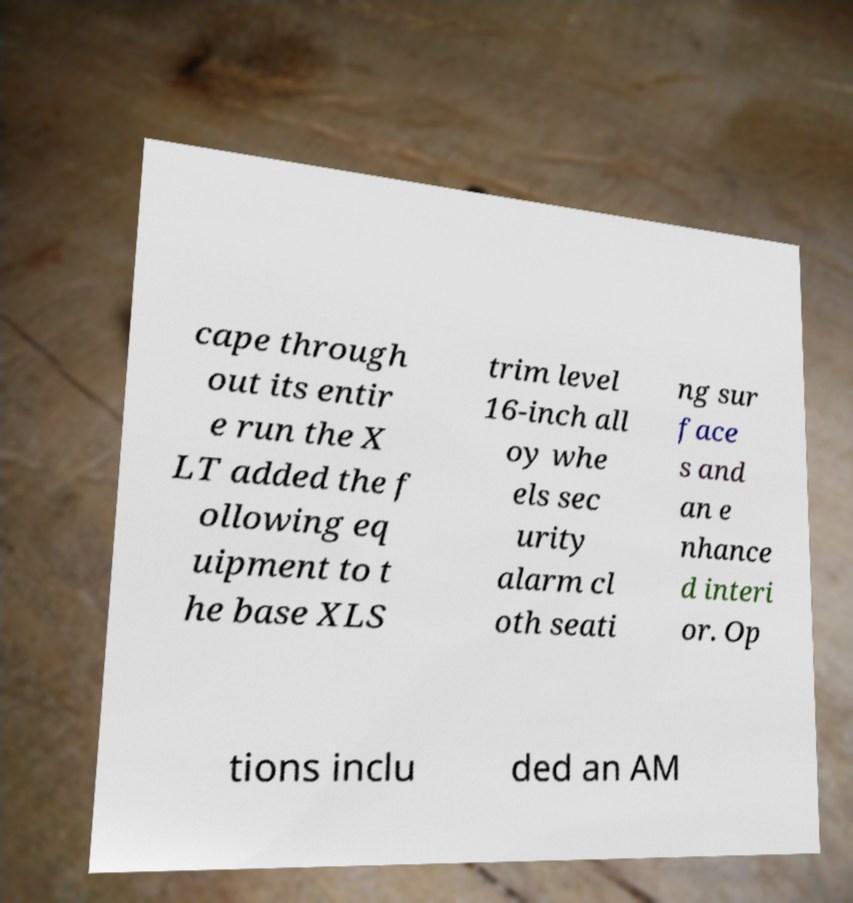Could you extract and type out the text from this image? cape through out its entir e run the X LT added the f ollowing eq uipment to t he base XLS trim level 16-inch all oy whe els sec urity alarm cl oth seati ng sur face s and an e nhance d interi or. Op tions inclu ded an AM 